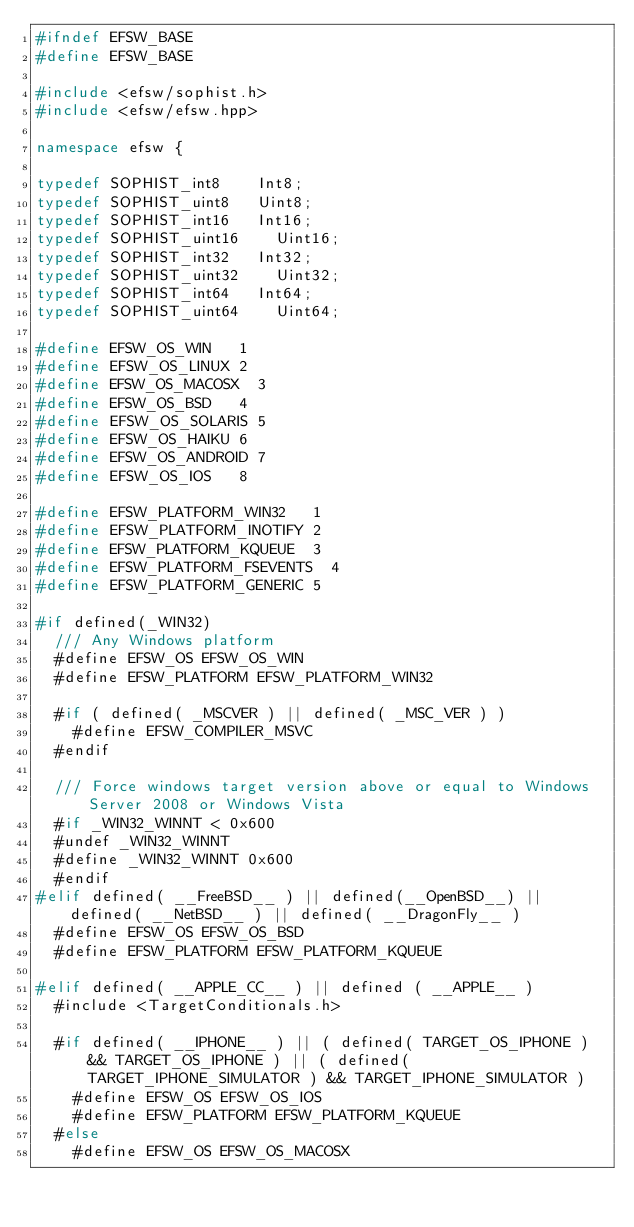<code> <loc_0><loc_0><loc_500><loc_500><_C++_>#ifndef EFSW_BASE
#define EFSW_BASE

#include <efsw/sophist.h>
#include <efsw/efsw.hpp>

namespace efsw {

typedef SOPHIST_int8		Int8;
typedef SOPHIST_uint8		Uint8;
typedef SOPHIST_int16		Int16;
typedef SOPHIST_uint16		Uint16;
typedef SOPHIST_int32		Int32;
typedef SOPHIST_uint32		Uint32;
typedef SOPHIST_int64		Int64;
typedef SOPHIST_uint64		Uint64;

#define EFSW_OS_WIN		1
#define EFSW_OS_LINUX	2
#define EFSW_OS_MACOSX	3
#define EFSW_OS_BSD		4
#define EFSW_OS_SOLARIS	5
#define EFSW_OS_HAIKU	6
#define EFSW_OS_ANDROID	7
#define EFSW_OS_IOS		8

#define EFSW_PLATFORM_WIN32		1
#define EFSW_PLATFORM_INOTIFY	2
#define EFSW_PLATFORM_KQUEUE	3
#define EFSW_PLATFORM_FSEVENTS	4
#define EFSW_PLATFORM_GENERIC	5

#if defined(_WIN32)
	///	Any Windows platform
	#define EFSW_OS EFSW_OS_WIN
	#define EFSW_PLATFORM EFSW_PLATFORM_WIN32

	#if ( defined( _MSCVER ) || defined( _MSC_VER ) )
		#define EFSW_COMPILER_MSVC
	#endif
	
	/// Force windows target version above or equal to Windows Server 2008 or Windows Vista
	#if _WIN32_WINNT < 0x600
	#undef _WIN32_WINNT
	#define _WIN32_WINNT 0x600
	#endif
#elif defined( __FreeBSD__ ) || defined(__OpenBSD__) || defined( __NetBSD__ ) || defined( __DragonFly__ )
	#define EFSW_OS EFSW_OS_BSD
	#define EFSW_PLATFORM EFSW_PLATFORM_KQUEUE

#elif defined( __APPLE_CC__ ) || defined ( __APPLE__ )
	#include <TargetConditionals.h>

	#if defined( __IPHONE__ ) || ( defined( TARGET_OS_IPHONE ) && TARGET_OS_IPHONE ) || ( defined( TARGET_IPHONE_SIMULATOR ) && TARGET_IPHONE_SIMULATOR )
		#define EFSW_OS EFSW_OS_IOS
		#define EFSW_PLATFORM EFSW_PLATFORM_KQUEUE
	#else
		#define EFSW_OS EFSW_OS_MACOSX
</code> 